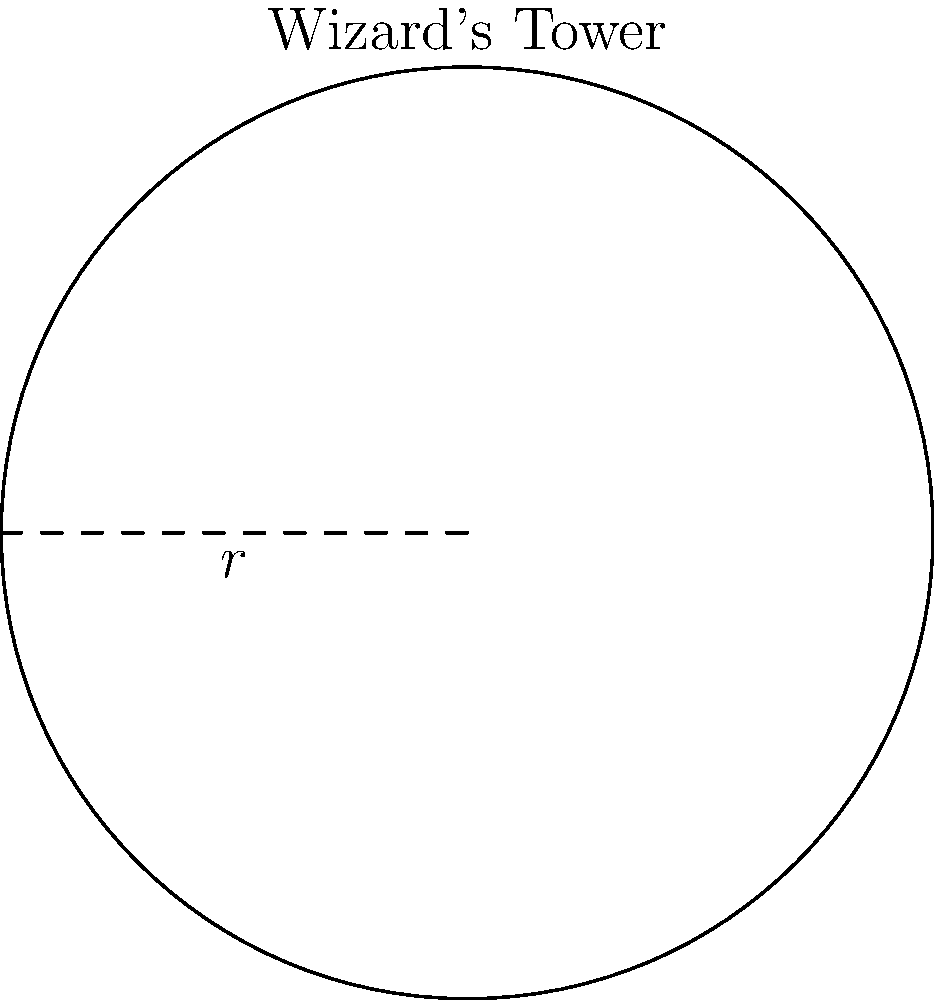In a magical realm, there's a circular wizard's tower with a radius of 21 feet. As a devoted collector of fantasy illustrations, you're tasked with calculating the perimeter of this mystical structure. What is the perimeter of the wizard's tower, rounded to the nearest foot? To find the perimeter of the circular wizard's tower, we need to use the formula for the circumference of a circle:

$C = 2\pi r$

Where:
$C$ is the circumference (perimeter)
$\pi$ is approximately 3.14159
$r$ is the radius

Given:
Radius ($r$) = 21 feet

Step 1: Substitute the values into the formula
$C = 2\pi(21)$

Step 2: Multiply
$C = 2(3.14159)(21)$
$C = 131.94678$ feet

Step 3: Round to the nearest foot
$C \approx 132$ feet

Therefore, the perimeter of the wizard's tower is approximately 132 feet.
Answer: 132 feet 